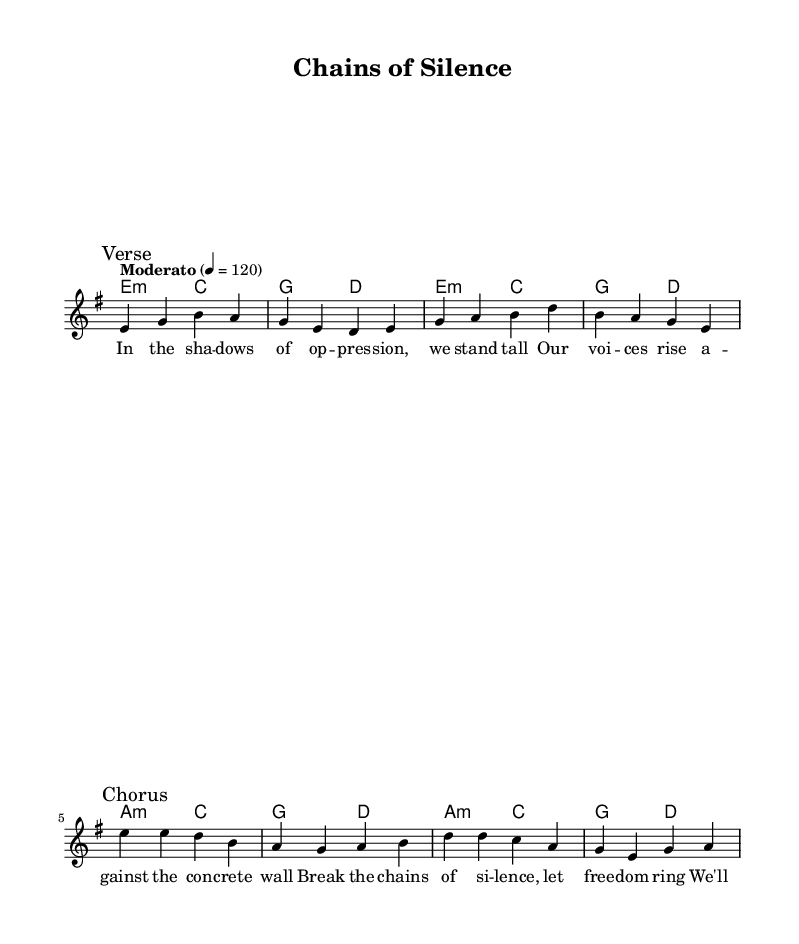What is the key signature of this music? The key signature indicates the key of E minor, which has one sharp (F#). This conclusion is drawn from the key signature marking shown at the beginning of the piece that establishes the tonal center of the melody.
Answer: E minor What is the time signature of this music? The time signature shown in the music is 4/4, which means there are four beats in each measure and the quarter note gets one beat. This is visually represented at the beginning of the score along with the key signature.
Answer: 4/4 What is the tempo marking for this piece? The tempo marking states "Moderato" and indicates a speed of 120 beats per minute, which suggests a moderate pace. This is located at the beginning, next to the time signature.
Answer: Moderato, 120 How many measures are in the verse section? By counting the measures in the melody section designated as "Verse," we see that there are four measures. Each measure is clearly delineated, making it easy to count them.
Answer: 4 What is the primary theme of the lyrics? The primarily expressed theme in the lyrics is one of resistance and pursuit of freedom. The word "break" and references to "chains of silence" encapsulate the protest nature of the song against oppression.
Answer: Resistance and freedom How does the harmony change during the chorus? In the chorus, the harmony transitions to predominantly minor chords such as A minor and maintains a similar rhythmic pattern, reflecting the shift in emotional intensity and lyrical message. This is derived from analyzing the chord progression specific to the chorus section.
Answer: A minor, C major What is the final outcome suggested by the lyrics? The lyrics culminate in an assertion of future hope and resilience, suggesting that the fight will continue, and they will "sing" a new song together. This encapsulates the overarching message of a relentless struggle against oppression.
Answer: Hope and resilience 